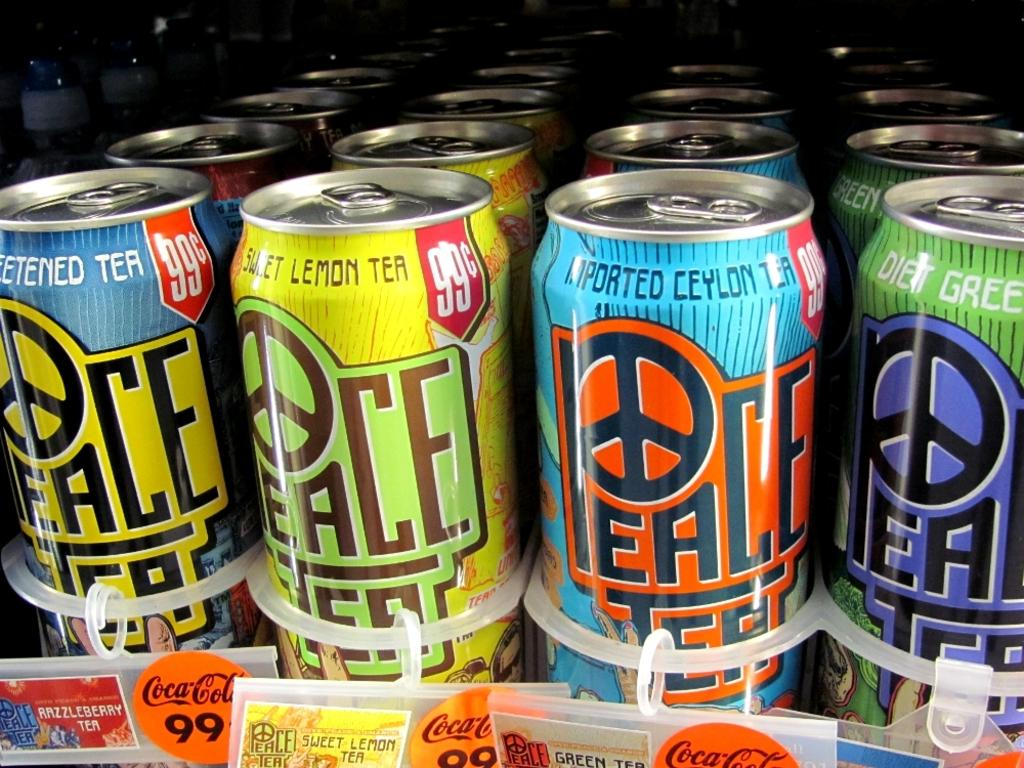<image>
Create a compact narrative representing the image presented. Different varieties of tea are displayed, in flavors like diet green, sweet lemon and imported ceylon. 